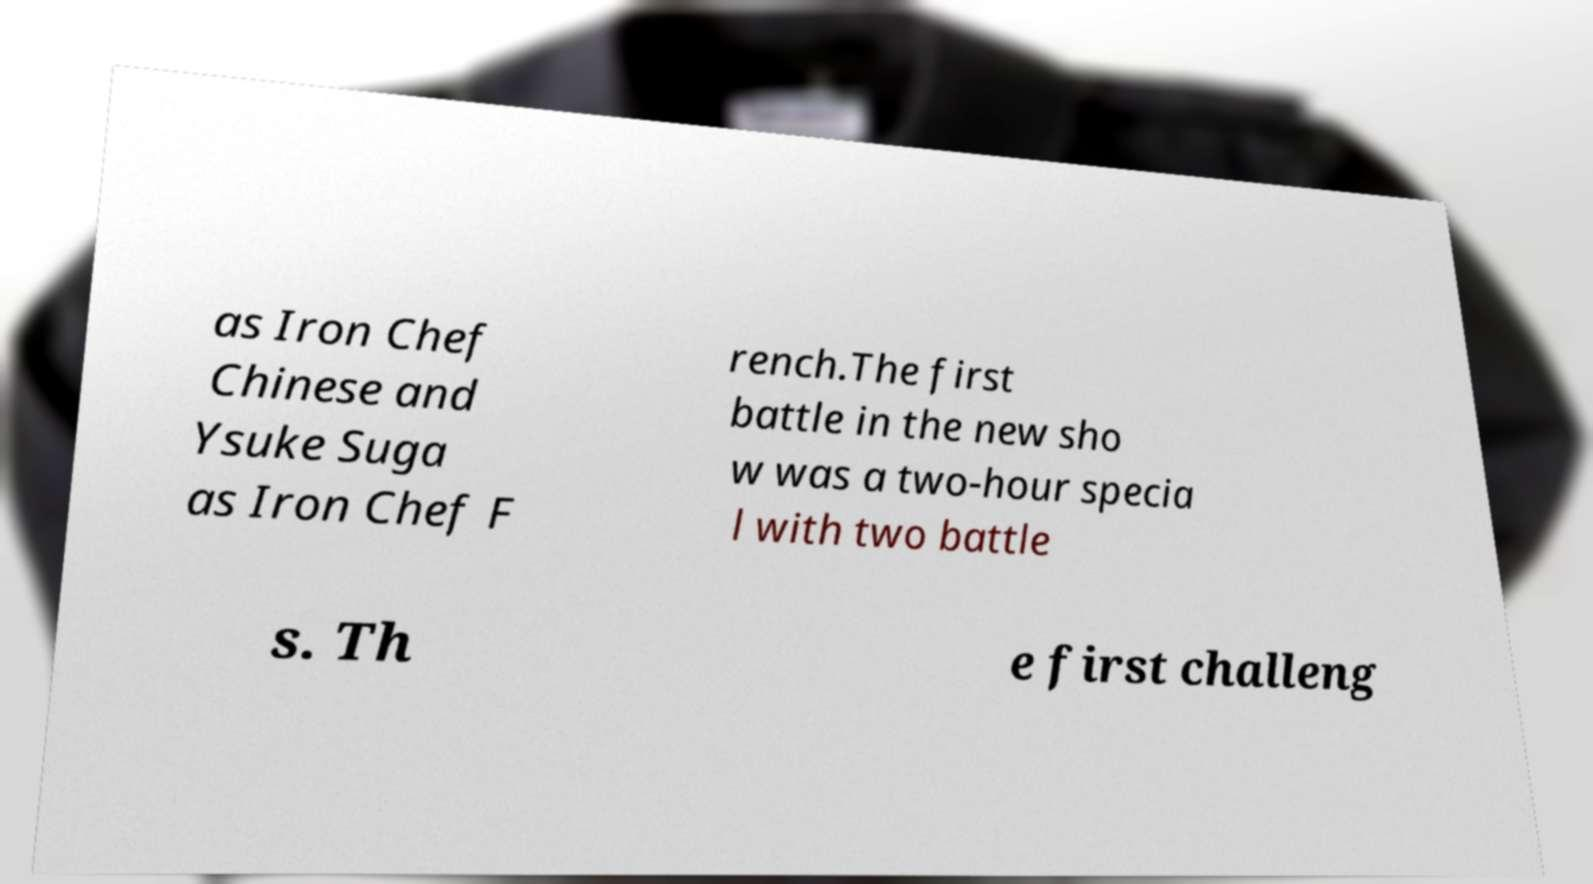I need the written content from this picture converted into text. Can you do that? as Iron Chef Chinese and Ysuke Suga as Iron Chef F rench.The first battle in the new sho w was a two-hour specia l with two battle s. Th e first challeng 